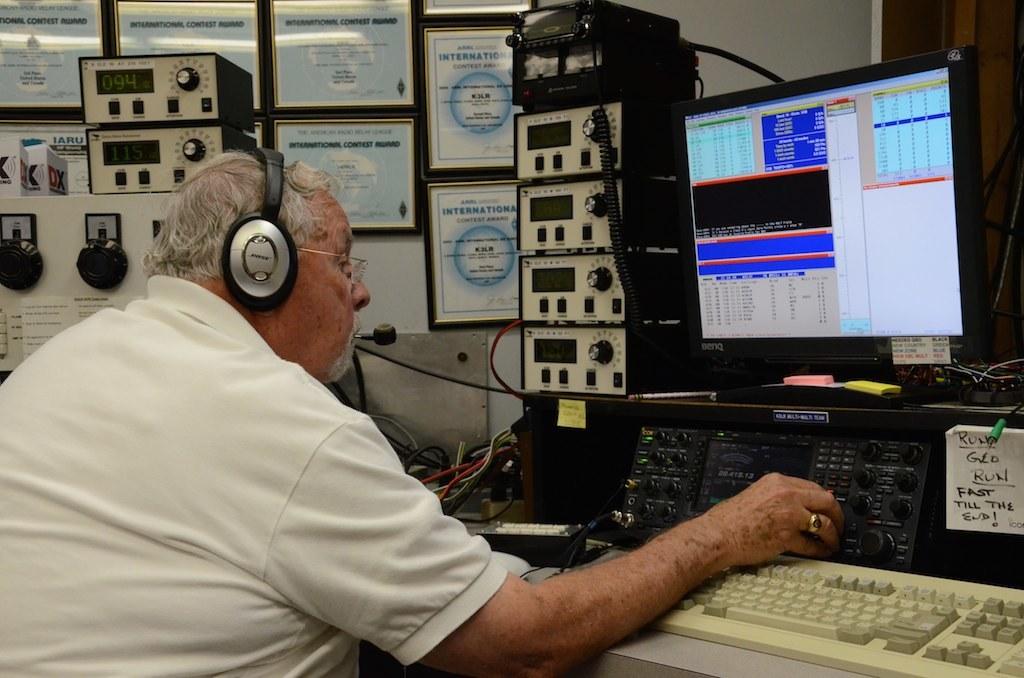Who makes the headphones?
Keep it short and to the point. Bose. What speed is referenced on the note to the right of the man's hand?
Your answer should be compact. Fast. 